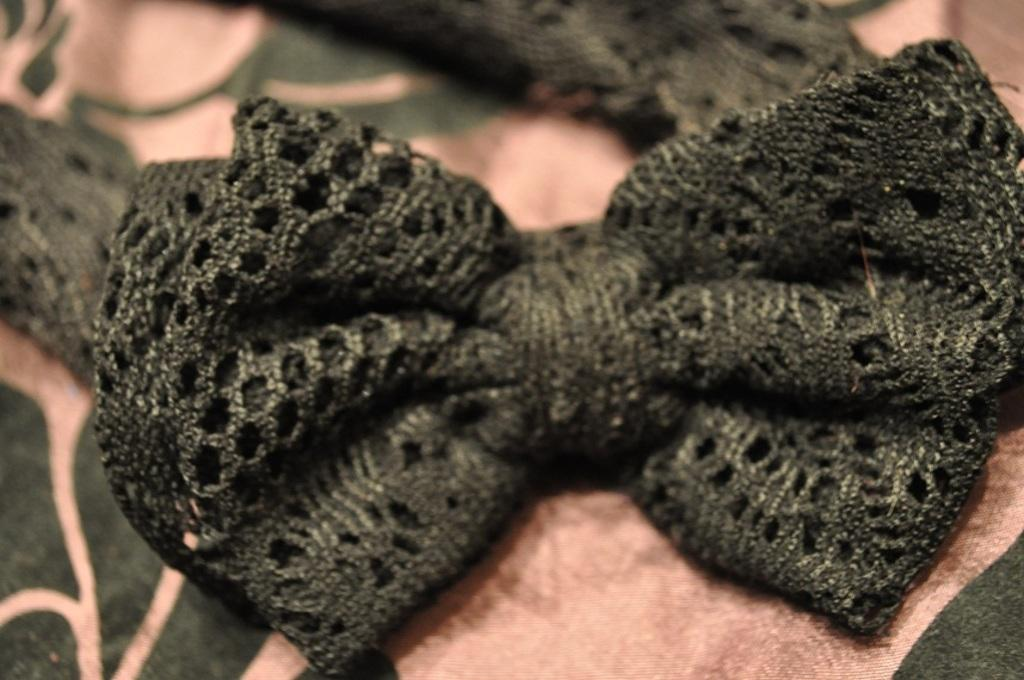What is the main subject of the image? The main subject of the image is a bow tie. Where is the bow tie located in the image? The bow tie is located in the middle of the image. What type of fan is visible in the image? There is no fan present in the image; it only features a bow tie. What color is the skin of the person wearing the bow tie in the image? There is no person wearing the bow tie in the image, as it only shows the bow tie itself. 